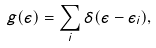<formula> <loc_0><loc_0><loc_500><loc_500>g ( \epsilon ) = \sum _ { i } \delta ( \epsilon - \epsilon _ { i } ) ,</formula> 